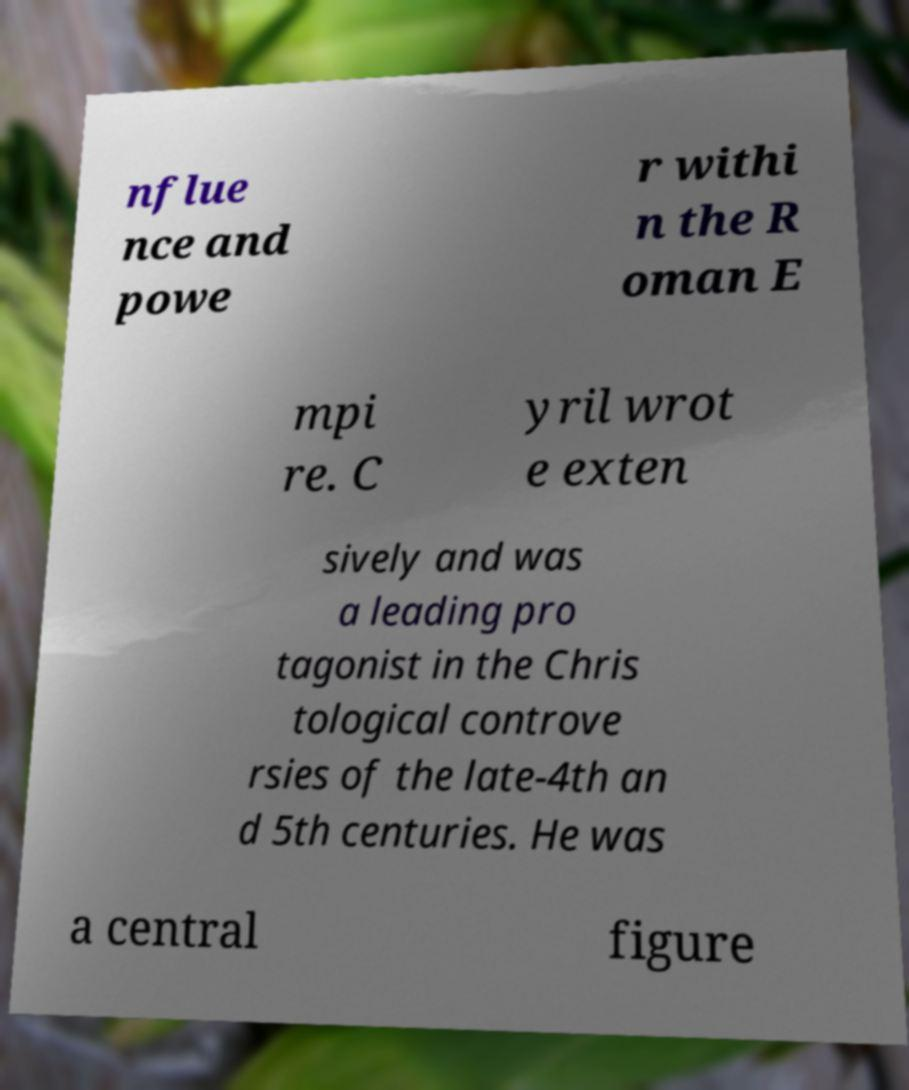There's text embedded in this image that I need extracted. Can you transcribe it verbatim? nflue nce and powe r withi n the R oman E mpi re. C yril wrot e exten sively and was a leading pro tagonist in the Chris tological controve rsies of the late-4th an d 5th centuries. He was a central figure 